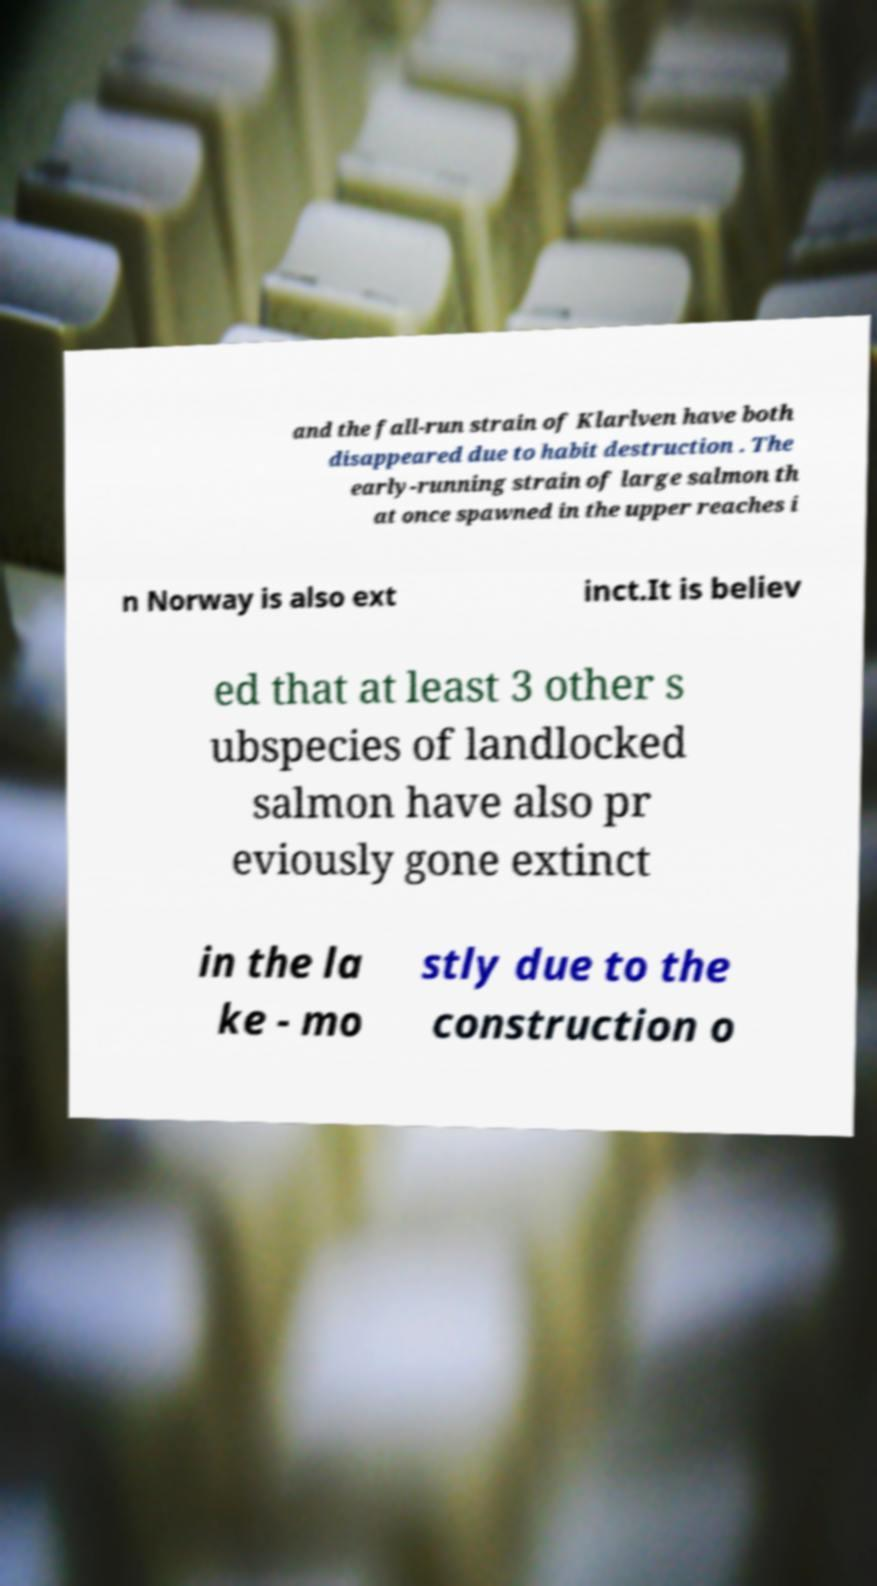Please read and relay the text visible in this image. What does it say? and the fall-run strain of Klarlven have both disappeared due to habit destruction . The early-running strain of large salmon th at once spawned in the upper reaches i n Norway is also ext inct.It is believ ed that at least 3 other s ubspecies of landlocked salmon have also pr eviously gone extinct in the la ke - mo stly due to the construction o 